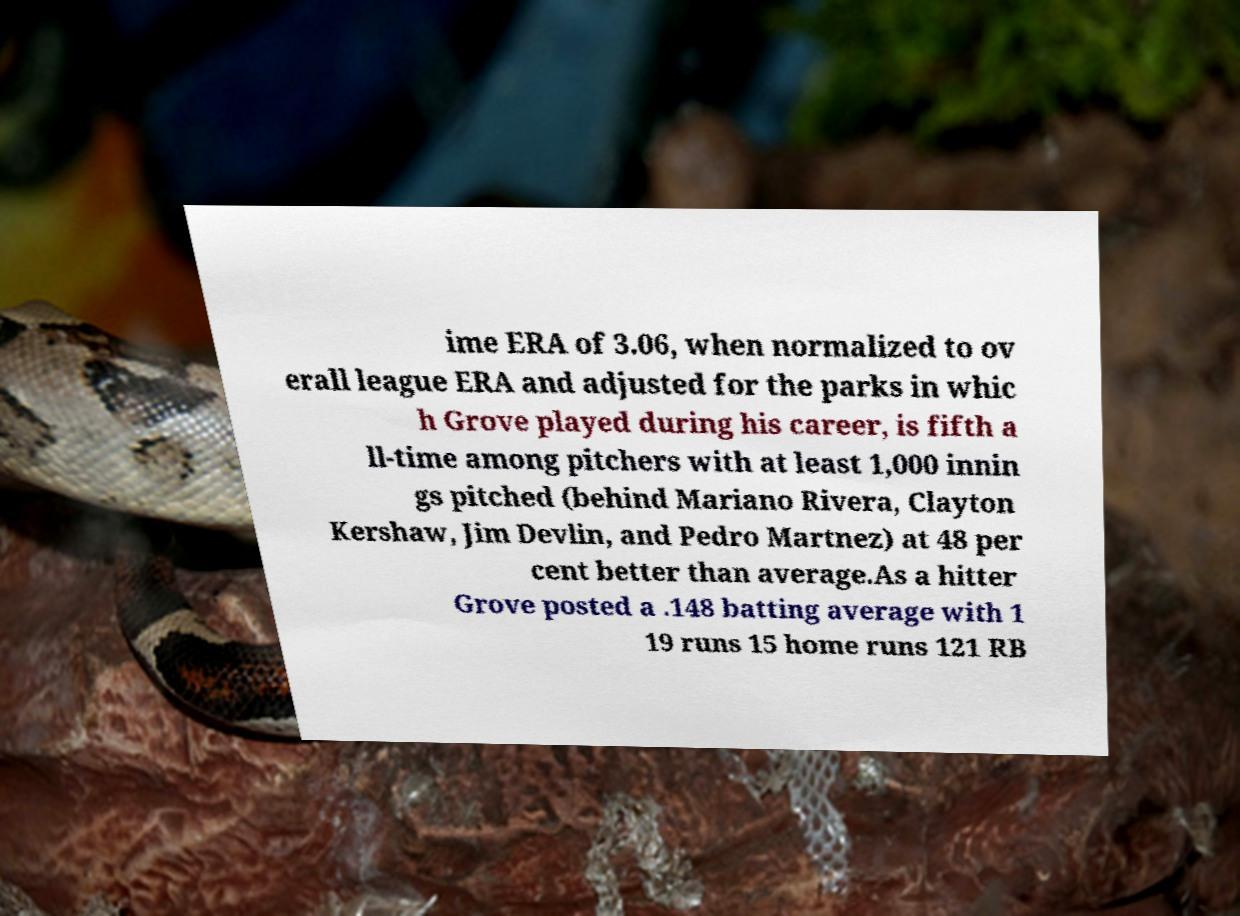Please read and relay the text visible in this image. What does it say? ime ERA of 3.06, when normalized to ov erall league ERA and adjusted for the parks in whic h Grove played during his career, is fifth a ll-time among pitchers with at least 1,000 innin gs pitched (behind Mariano Rivera, Clayton Kershaw, Jim Devlin, and Pedro Martnez) at 48 per cent better than average.As a hitter Grove posted a .148 batting average with 1 19 runs 15 home runs 121 RB 